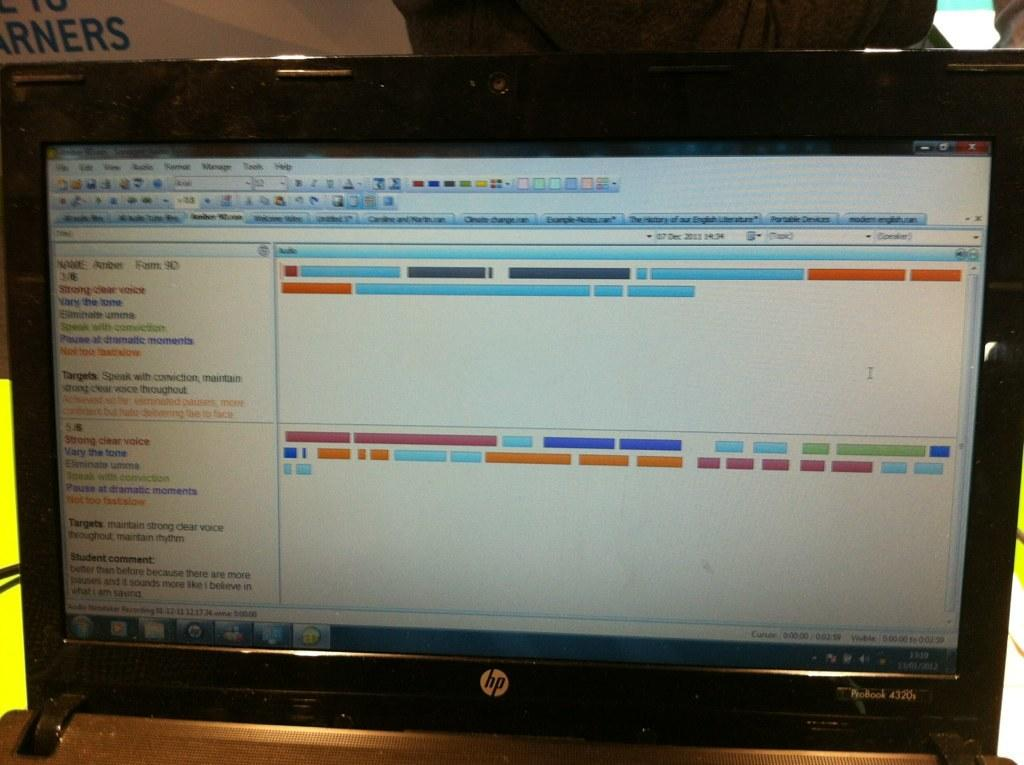<image>
Give a short and clear explanation of the subsequent image. A screen that is turned on and has the HP logo beneath it. 